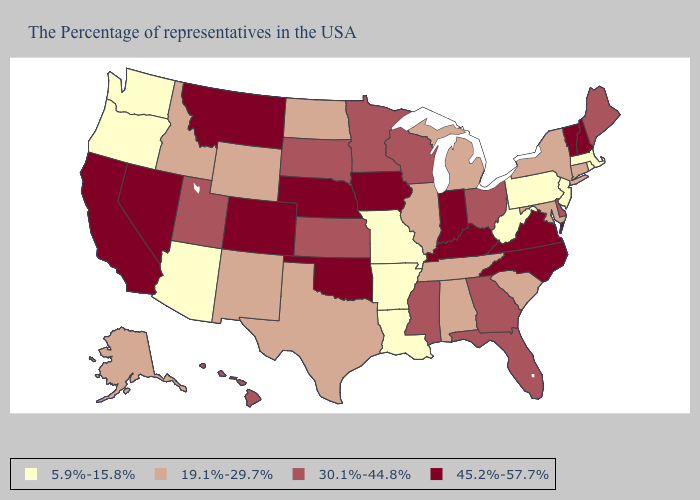Does Kansas have a higher value than Minnesota?
Keep it brief. No. Which states hav the highest value in the MidWest?
Give a very brief answer. Indiana, Iowa, Nebraska. Which states have the lowest value in the USA?
Keep it brief. Massachusetts, Rhode Island, New Jersey, Pennsylvania, West Virginia, Louisiana, Missouri, Arkansas, Arizona, Washington, Oregon. Does the map have missing data?
Answer briefly. No. Does South Dakota have the highest value in the MidWest?
Answer briefly. No. What is the highest value in the USA?
Be succinct. 45.2%-57.7%. Does Washington have the same value as Pennsylvania?
Concise answer only. Yes. What is the highest value in the Northeast ?
Keep it brief. 45.2%-57.7%. What is the value of Arizona?
Quick response, please. 5.9%-15.8%. What is the highest value in the USA?
Quick response, please. 45.2%-57.7%. Name the states that have a value in the range 30.1%-44.8%?
Give a very brief answer. Maine, Delaware, Ohio, Florida, Georgia, Wisconsin, Mississippi, Minnesota, Kansas, South Dakota, Utah, Hawaii. Name the states that have a value in the range 5.9%-15.8%?
Give a very brief answer. Massachusetts, Rhode Island, New Jersey, Pennsylvania, West Virginia, Louisiana, Missouri, Arkansas, Arizona, Washington, Oregon. Does the map have missing data?
Quick response, please. No. What is the value of Iowa?
Be succinct. 45.2%-57.7%. 